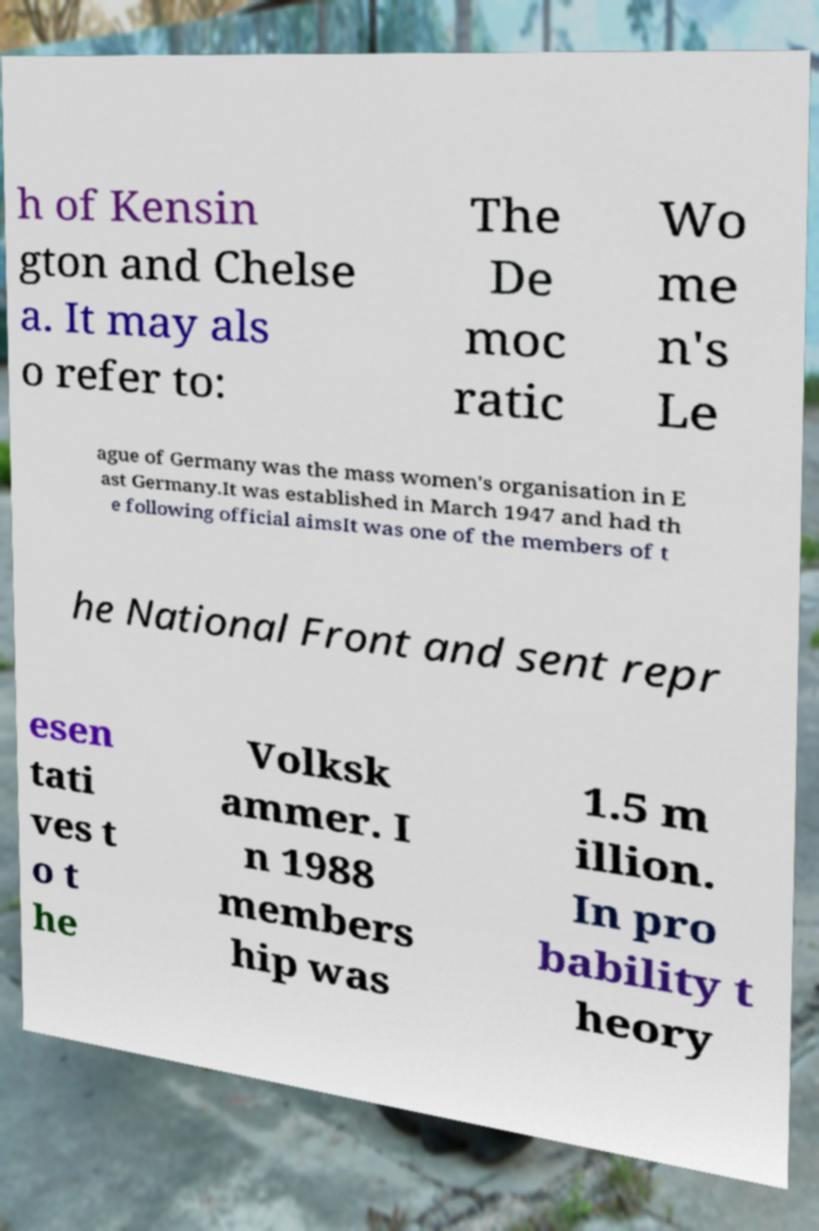What messages or text are displayed in this image? I need them in a readable, typed format. h of Kensin gton and Chelse a. It may als o refer to: The De moc ratic Wo me n's Le ague of Germany was the mass women's organisation in E ast Germany.It was established in March 1947 and had th e following official aimsIt was one of the members of t he National Front and sent repr esen tati ves t o t he Volksk ammer. I n 1988 members hip was 1.5 m illion. In pro bability t heory 